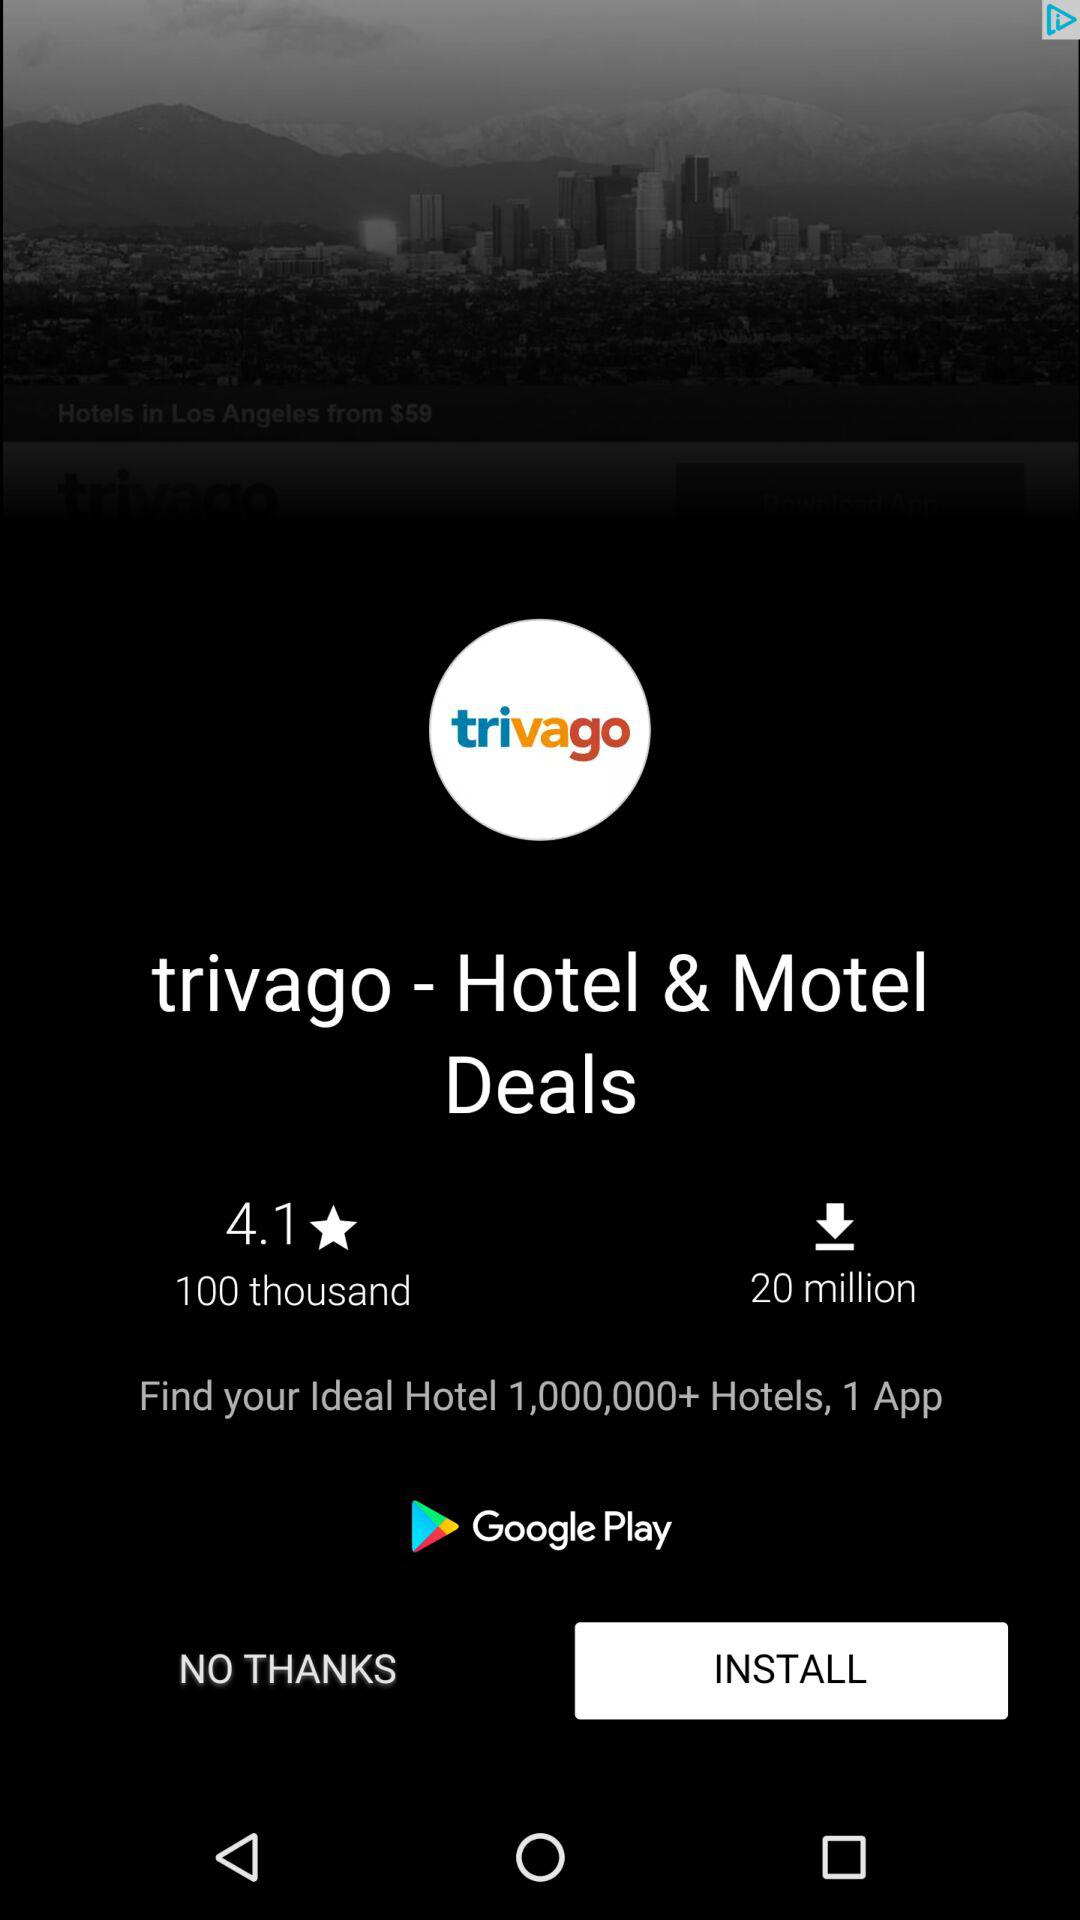How many reviews does trivago have?
Answer the question using a single word or phrase. 100 thousand 